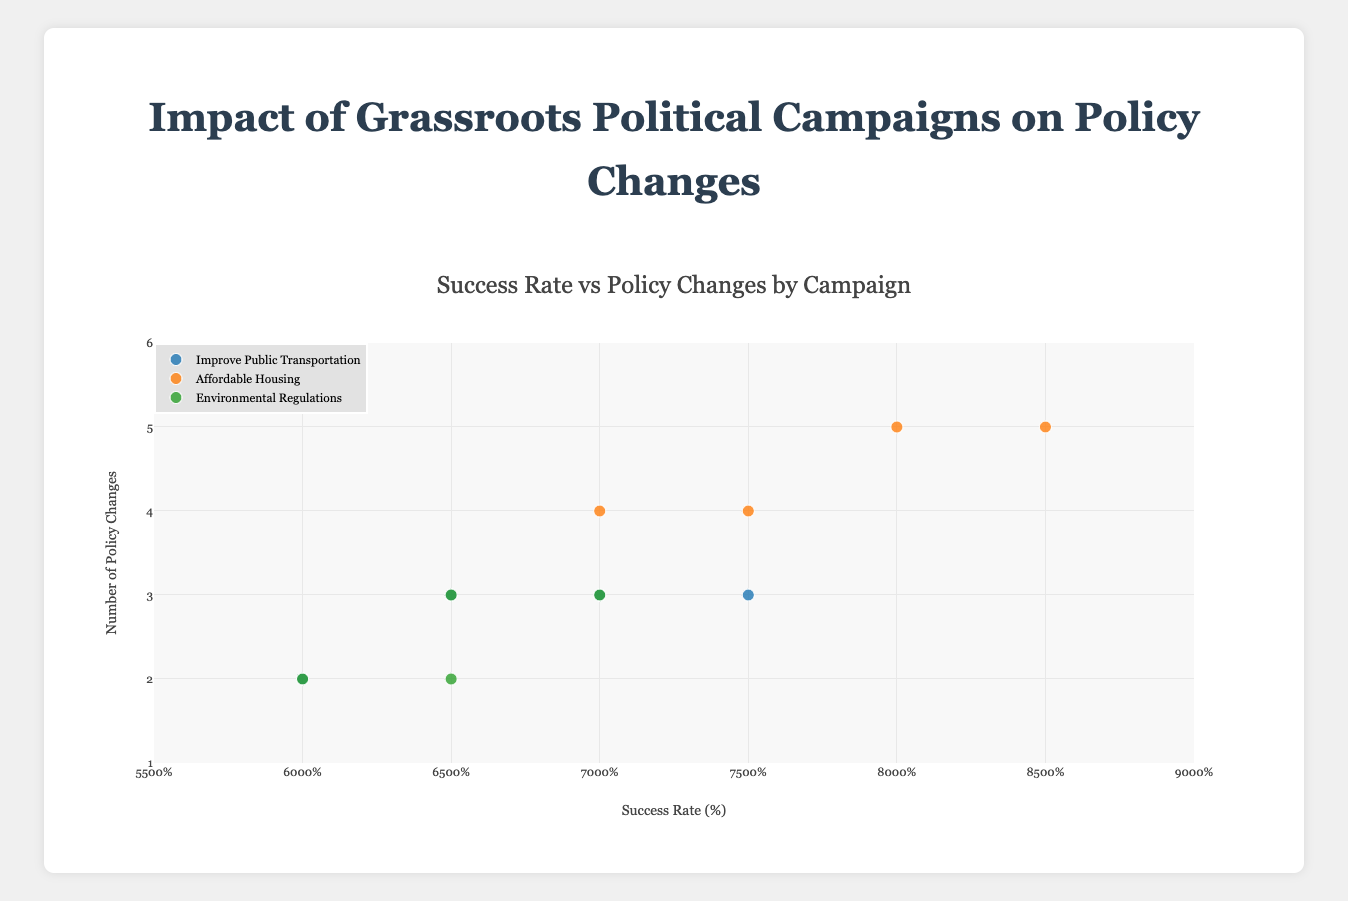What campaigns are included in the figure? The figure shows the impact of three different grassroots political campaigns. This can be seen from the legend, which lists "Improve Public Transportation," "Affordable Housing," and "Environmental Regulations."
Answer: Improve Public Transportation, Affordable Housing, Environmental Regulations For the campaign "Affordable Housing" in San Francisco, which demographic group has the highest success rate? By looking at the markers for the "Affordable Housing" campaign in San Francisco, we can observe the markers for different demographic groups. The success rates are listed, and the group with the highest success rate is the "White" population age group "18-35."
Answer: White population age group 18-35 How many policy changes are there for the "Environmental Regulations" campaign with a success rate of 70%? The "Environmental Regulations" campaign with a success rate of 70% can be identified by its marker color. The number of policy changes for this success rate is represented along the y-axis. The marker at 70% success rate corresponds to 3 policy changes.
Answer: 3 Comparing the "Improve Public Transportation" campaign, which age group in Austin has a higher success rate among Hispanic population, 18-35 or 36-60? The markers for the "Improve Public Transportation" campaign in Austin can be examined. The success rate for the 18-35 age group is 75%, and for the 36-60 age group, it is 60%. Therefore, the 18-35 age group has a higher success rate.
Answer: 18-35 Which campaign has the highest number of policy changes for the campaign with the highest success rate among all data points? To find this, we compare the success rates and the corresponding number of policy changes across all campaigns. The highest success rate is 85%, which is for the "Affordable Housing" campaign. The number of policy changes for this campaign is 5.
Answer: Affordable Housing What is the average number of policy changes for the "Improve Public Transportation" campaign in Austin? To calculate the average, add the number of policy changes for each demographic group and divide by the number of data points. The policy changes (3, 2, 3, and 3) sum to 11. There are four data points, so the average is 11/4.
Answer: 2.75 Among the age groups of 18-35 and 36-60 in Austin for the "Improve Public Transportation" campaign, which demographic has more policy changes on average? First, sum the policy changes for each age group. For 18-35: (3 + 3) = 6. For 36-60: (2 + 3) = 5. Then, divide by the number of data points for each group. The average for 18-35: 6/2 = 3. The average for 36-60: 5/2 = 2.5.
Answer: 18-35 What is the total number of policy changes for the "Environmental Regulations" campaign across all municipalities? Sum the policy changes for all demographic groups within the "Environmental Regulations" campaign. The policy changes are (3 + 2 + 3 + 2) = 10.
Answer: 10 